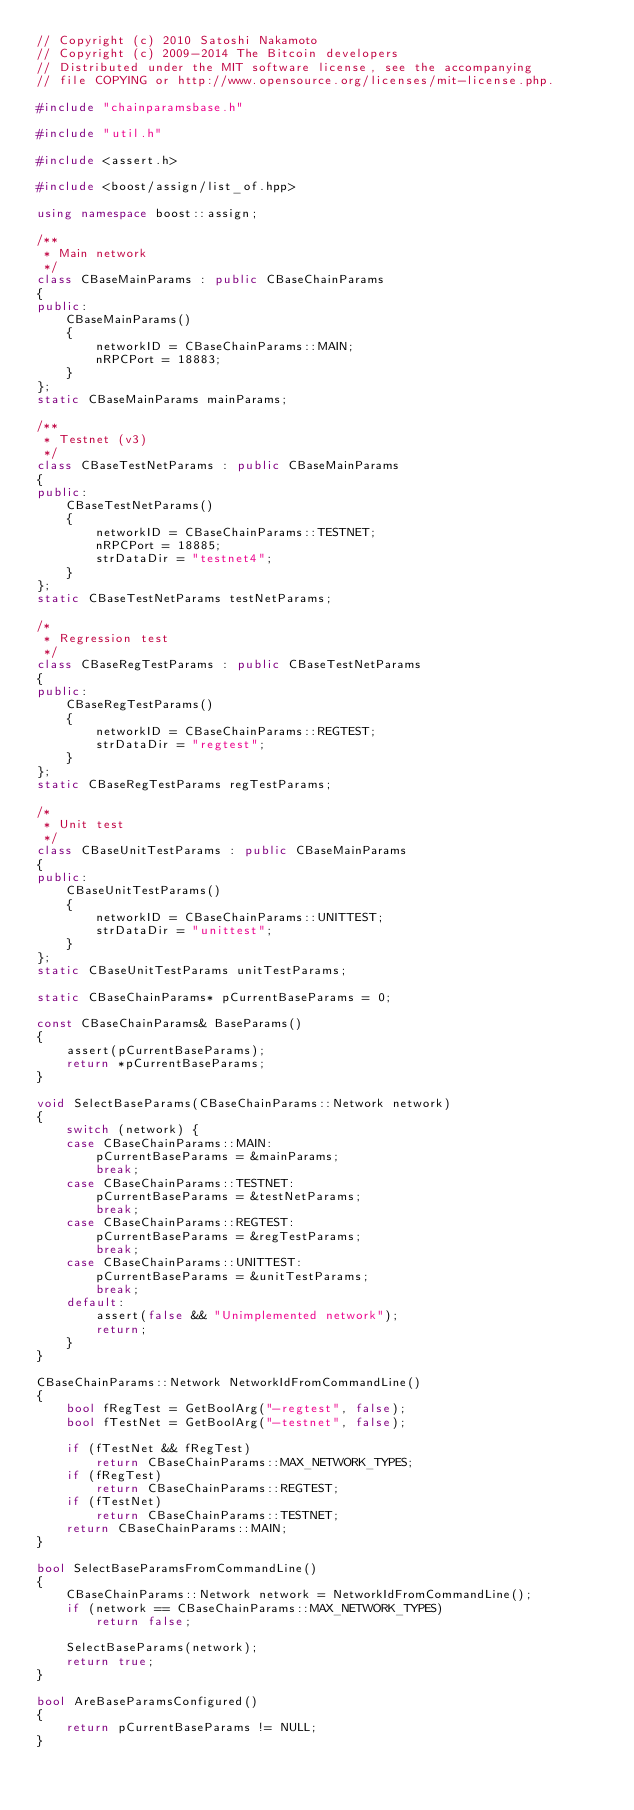Convert code to text. <code><loc_0><loc_0><loc_500><loc_500><_C++_>// Copyright (c) 2010 Satoshi Nakamoto
// Copyright (c) 2009-2014 The Bitcoin developers
// Distributed under the MIT software license, see the accompanying
// file COPYING or http://www.opensource.org/licenses/mit-license.php.

#include "chainparamsbase.h"

#include "util.h"

#include <assert.h>

#include <boost/assign/list_of.hpp>

using namespace boost::assign;

/**
 * Main network
 */
class CBaseMainParams : public CBaseChainParams
{
public:
    CBaseMainParams()
    {
        networkID = CBaseChainParams::MAIN;
        nRPCPort = 18883;
    }
};
static CBaseMainParams mainParams;

/**
 * Testnet (v3)
 */
class CBaseTestNetParams : public CBaseMainParams
{
public:
    CBaseTestNetParams()
    {
        networkID = CBaseChainParams::TESTNET;
        nRPCPort = 18885;
        strDataDir = "testnet4";
    }
};
static CBaseTestNetParams testNetParams;

/*
 * Regression test
 */
class CBaseRegTestParams : public CBaseTestNetParams
{
public:
    CBaseRegTestParams()
    {
        networkID = CBaseChainParams::REGTEST;
        strDataDir = "regtest";
    }
};
static CBaseRegTestParams regTestParams;

/*
 * Unit test
 */
class CBaseUnitTestParams : public CBaseMainParams
{
public:
    CBaseUnitTestParams()
    {
        networkID = CBaseChainParams::UNITTEST;
        strDataDir = "unittest";
    }
};
static CBaseUnitTestParams unitTestParams;

static CBaseChainParams* pCurrentBaseParams = 0;

const CBaseChainParams& BaseParams()
{
    assert(pCurrentBaseParams);
    return *pCurrentBaseParams;
}

void SelectBaseParams(CBaseChainParams::Network network)
{
    switch (network) {
    case CBaseChainParams::MAIN:
        pCurrentBaseParams = &mainParams;
        break;
    case CBaseChainParams::TESTNET:
        pCurrentBaseParams = &testNetParams;
        break;
    case CBaseChainParams::REGTEST:
        pCurrentBaseParams = &regTestParams;
        break;
    case CBaseChainParams::UNITTEST:
        pCurrentBaseParams = &unitTestParams;
        break;
    default:
        assert(false && "Unimplemented network");
        return;
    }
}

CBaseChainParams::Network NetworkIdFromCommandLine()
{
    bool fRegTest = GetBoolArg("-regtest", false);
    bool fTestNet = GetBoolArg("-testnet", false);

    if (fTestNet && fRegTest)
        return CBaseChainParams::MAX_NETWORK_TYPES;
    if (fRegTest)
        return CBaseChainParams::REGTEST;
    if (fTestNet)
        return CBaseChainParams::TESTNET;
    return CBaseChainParams::MAIN;
}

bool SelectBaseParamsFromCommandLine()
{
    CBaseChainParams::Network network = NetworkIdFromCommandLine();
    if (network == CBaseChainParams::MAX_NETWORK_TYPES)
        return false;

    SelectBaseParams(network);
    return true;
}

bool AreBaseParamsConfigured()
{
    return pCurrentBaseParams != NULL;
}
</code> 